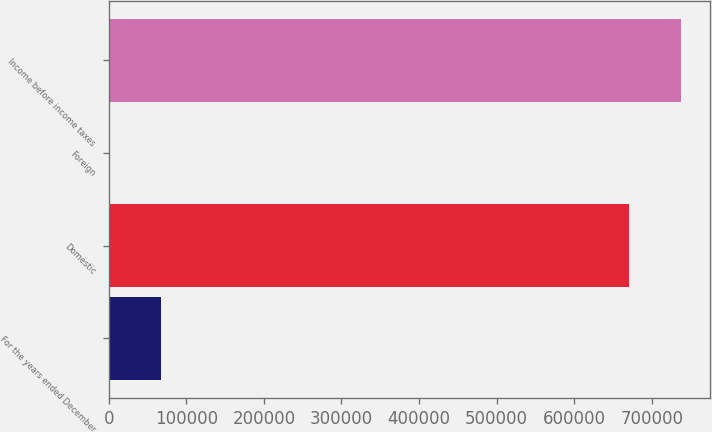Convert chart to OTSL. <chart><loc_0><loc_0><loc_500><loc_500><bar_chart><fcel>For the years ended December<fcel>Domestic<fcel>Foreign<fcel>Income before income taxes<nl><fcel>67453.3<fcel>670753<fcel>378<fcel>737828<nl></chart> 